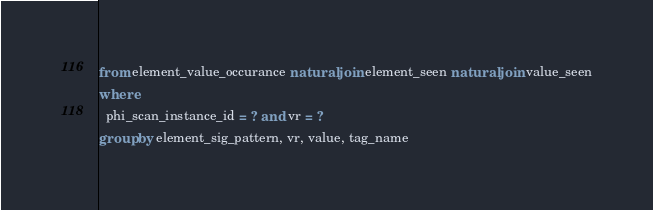<code> <loc_0><loc_0><loc_500><loc_500><_SQL_>from element_value_occurance natural join element_seen natural join value_seen
where 
  phi_scan_instance_id = ? and vr = ?
group by element_sig_pattern, vr, value, tag_name</code> 